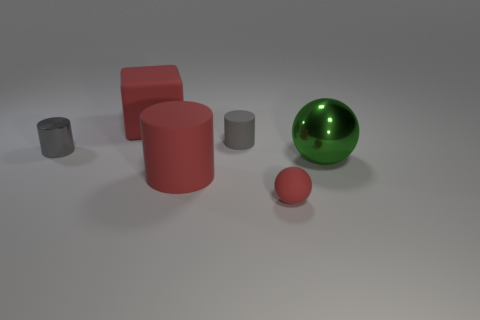Is there another red matte thing that has the same shape as the tiny red rubber thing?
Make the answer very short. No. There is a gray metal object that is the same size as the red ball; what shape is it?
Provide a succinct answer. Cylinder. How many things are large red objects that are in front of the big cube or tiny cyan metal blocks?
Ensure brevity in your answer.  1. Does the tiny sphere have the same color as the big matte cylinder?
Ensure brevity in your answer.  Yes. What is the size of the red object behind the red cylinder?
Your answer should be compact. Large. Is there a red ball of the same size as the green thing?
Give a very brief answer. No. Is the size of the shiny thing that is right of the red block the same as the big red matte cylinder?
Offer a terse response. Yes. The green shiny ball has what size?
Keep it short and to the point. Large. There is a rubber cylinder in front of the tiny object that is to the left of the large object behind the gray shiny thing; what is its color?
Offer a very short reply. Red. There is a big matte object that is on the right side of the big red cube; is it the same color as the small shiny object?
Offer a terse response. No. 